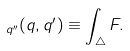<formula> <loc_0><loc_0><loc_500><loc_500>\ _ { q ^ { \prime \prime } } ( q , q ^ { \prime } ) \equiv \int _ { \triangle } F .</formula> 